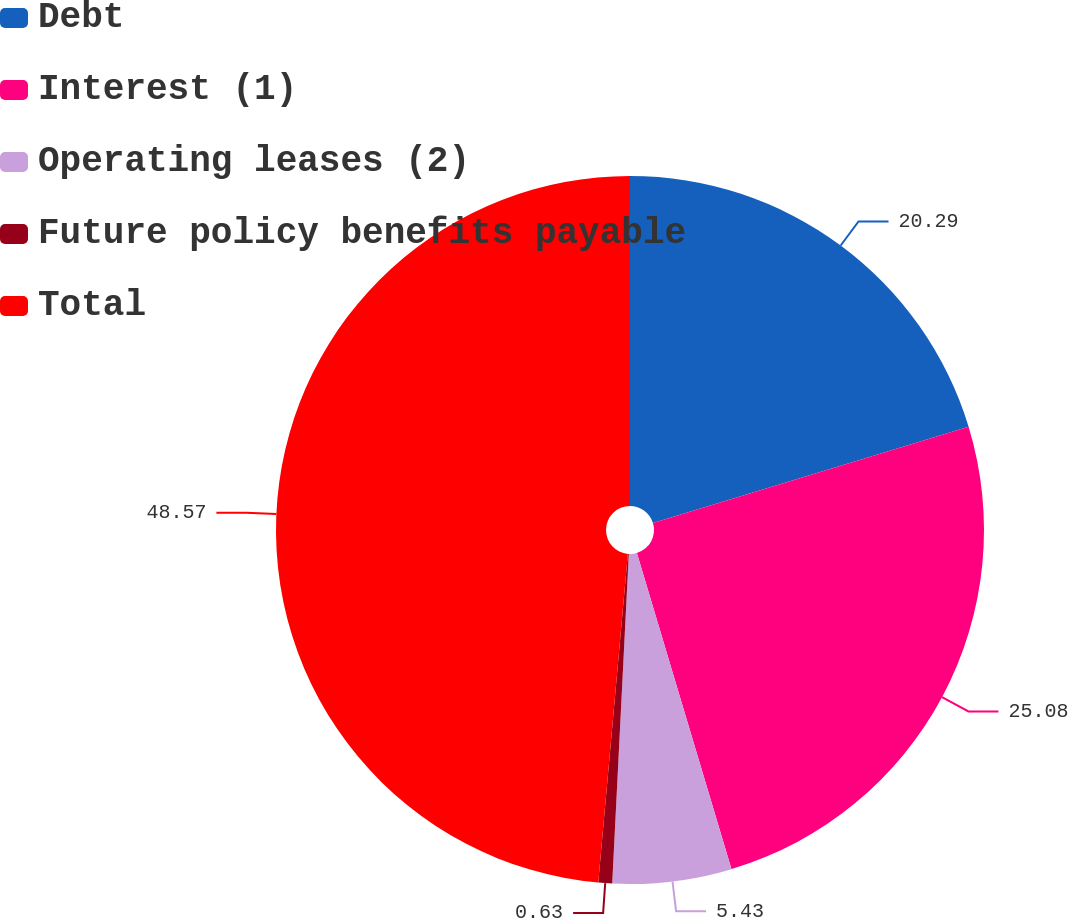<chart> <loc_0><loc_0><loc_500><loc_500><pie_chart><fcel>Debt<fcel>Interest (1)<fcel>Operating leases (2)<fcel>Future policy benefits payable<fcel>Total<nl><fcel>20.29%<fcel>25.08%<fcel>5.43%<fcel>0.63%<fcel>48.57%<nl></chart> 